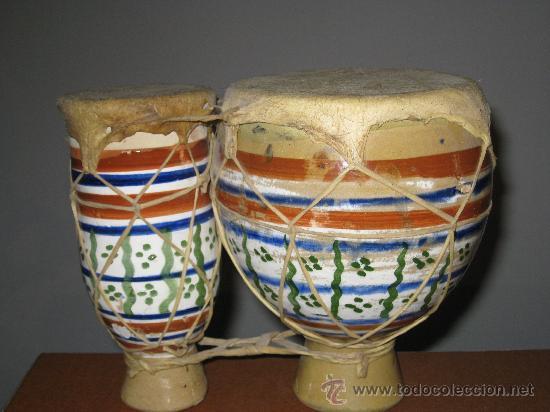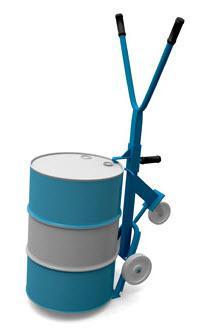The first image is the image on the left, the second image is the image on the right. Analyze the images presented: Is the assertion "There are four drum sticks." valid? Answer yes or no. No. 